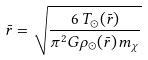<formula> <loc_0><loc_0><loc_500><loc_500>\bar { r } = \sqrt { \frac { 6 \, T _ { \odot } ( \bar { r } ) } { \pi ^ { 2 } G \rho _ { \odot } ( \bar { r } ) \, m _ { \chi } } }</formula> 